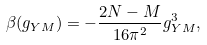Convert formula to latex. <formula><loc_0><loc_0><loc_500><loc_500>\beta ( g _ { Y M } ) = - \frac { 2 N - M } { 1 6 \pi ^ { 2 } } g _ { Y M } ^ { 3 } ,</formula> 